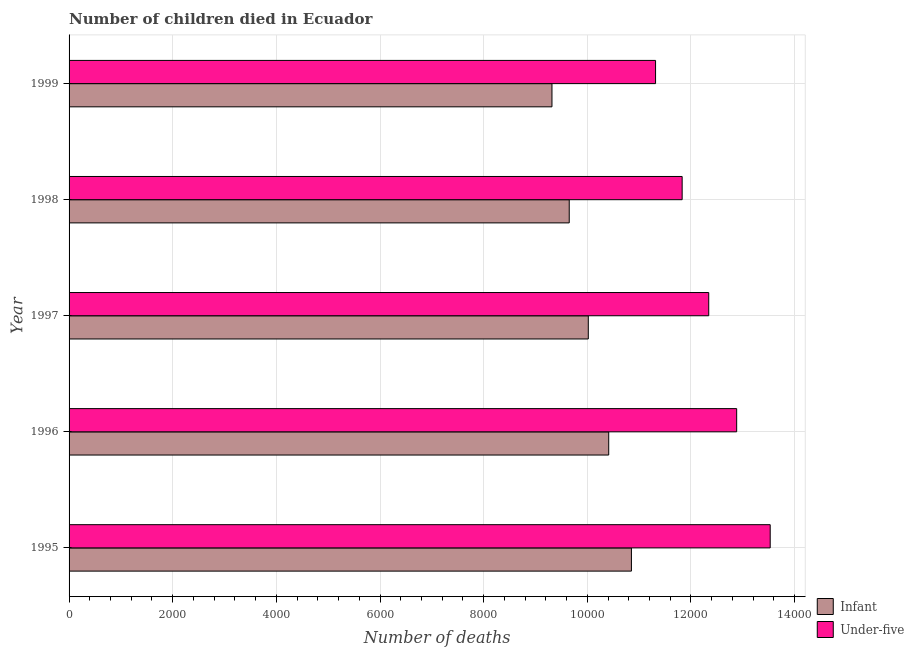How many bars are there on the 2nd tick from the top?
Offer a terse response. 2. What is the number of infant deaths in 1999?
Make the answer very short. 9318. Across all years, what is the maximum number of under-five deaths?
Keep it short and to the point. 1.35e+04. Across all years, what is the minimum number of infant deaths?
Ensure brevity in your answer.  9318. What is the total number of infant deaths in the graph?
Your answer should be very brief. 5.03e+04. What is the difference between the number of under-five deaths in 1995 and that in 1998?
Keep it short and to the point. 1699. What is the difference between the number of infant deaths in 1997 and the number of under-five deaths in 1996?
Your answer should be compact. -2863. What is the average number of infant deaths per year?
Offer a very short reply. 1.01e+04. In the year 1998, what is the difference between the number of under-five deaths and number of infant deaths?
Offer a terse response. 2179. In how many years, is the number of under-five deaths greater than 1200 ?
Offer a very short reply. 5. What is the ratio of the number of infant deaths in 1998 to that in 1999?
Give a very brief answer. 1.04. Is the number of infant deaths in 1995 less than that in 1998?
Make the answer very short. No. Is the difference between the number of under-five deaths in 1996 and 1999 greater than the difference between the number of infant deaths in 1996 and 1999?
Your answer should be very brief. Yes. What is the difference between the highest and the second highest number of under-five deaths?
Give a very brief answer. 647. What is the difference between the highest and the lowest number of under-five deaths?
Provide a short and direct response. 2212. Is the sum of the number of under-five deaths in 1995 and 1997 greater than the maximum number of infant deaths across all years?
Offer a terse response. Yes. What does the 2nd bar from the top in 1997 represents?
Give a very brief answer. Infant. What does the 1st bar from the bottom in 1995 represents?
Provide a succinct answer. Infant. How many years are there in the graph?
Provide a short and direct response. 5. What is the difference between two consecutive major ticks on the X-axis?
Keep it short and to the point. 2000. Are the values on the major ticks of X-axis written in scientific E-notation?
Provide a succinct answer. No. Does the graph contain grids?
Provide a succinct answer. Yes. How many legend labels are there?
Keep it short and to the point. 2. What is the title of the graph?
Provide a succinct answer. Number of children died in Ecuador. What is the label or title of the X-axis?
Offer a very short reply. Number of deaths. What is the label or title of the Y-axis?
Your answer should be very brief. Year. What is the Number of deaths in Infant in 1995?
Your answer should be compact. 1.09e+04. What is the Number of deaths of Under-five in 1995?
Keep it short and to the point. 1.35e+04. What is the Number of deaths of Infant in 1996?
Give a very brief answer. 1.04e+04. What is the Number of deaths of Under-five in 1996?
Offer a very short reply. 1.29e+04. What is the Number of deaths in Infant in 1997?
Your response must be concise. 1.00e+04. What is the Number of deaths in Under-five in 1997?
Keep it short and to the point. 1.23e+04. What is the Number of deaths of Infant in 1998?
Your response must be concise. 9651. What is the Number of deaths of Under-five in 1998?
Your answer should be very brief. 1.18e+04. What is the Number of deaths of Infant in 1999?
Offer a terse response. 9318. What is the Number of deaths of Under-five in 1999?
Provide a short and direct response. 1.13e+04. Across all years, what is the maximum Number of deaths in Infant?
Make the answer very short. 1.09e+04. Across all years, what is the maximum Number of deaths of Under-five?
Provide a short and direct response. 1.35e+04. Across all years, what is the minimum Number of deaths in Infant?
Provide a short and direct response. 9318. Across all years, what is the minimum Number of deaths in Under-five?
Your answer should be compact. 1.13e+04. What is the total Number of deaths in Infant in the graph?
Provide a short and direct response. 5.03e+04. What is the total Number of deaths in Under-five in the graph?
Ensure brevity in your answer.  6.19e+04. What is the difference between the Number of deaths of Infant in 1995 and that in 1996?
Offer a very short reply. 438. What is the difference between the Number of deaths in Under-five in 1995 and that in 1996?
Provide a short and direct response. 647. What is the difference between the Number of deaths in Infant in 1995 and that in 1997?
Your answer should be very brief. 832. What is the difference between the Number of deaths in Under-five in 1995 and that in 1997?
Offer a terse response. 1186. What is the difference between the Number of deaths of Infant in 1995 and that in 1998?
Provide a short and direct response. 1200. What is the difference between the Number of deaths in Under-five in 1995 and that in 1998?
Give a very brief answer. 1699. What is the difference between the Number of deaths in Infant in 1995 and that in 1999?
Make the answer very short. 1533. What is the difference between the Number of deaths of Under-five in 1995 and that in 1999?
Make the answer very short. 2212. What is the difference between the Number of deaths of Infant in 1996 and that in 1997?
Offer a terse response. 394. What is the difference between the Number of deaths in Under-five in 1996 and that in 1997?
Your response must be concise. 539. What is the difference between the Number of deaths in Infant in 1996 and that in 1998?
Offer a very short reply. 762. What is the difference between the Number of deaths of Under-five in 1996 and that in 1998?
Offer a very short reply. 1052. What is the difference between the Number of deaths of Infant in 1996 and that in 1999?
Provide a succinct answer. 1095. What is the difference between the Number of deaths in Under-five in 1996 and that in 1999?
Make the answer very short. 1565. What is the difference between the Number of deaths of Infant in 1997 and that in 1998?
Offer a terse response. 368. What is the difference between the Number of deaths of Under-five in 1997 and that in 1998?
Ensure brevity in your answer.  513. What is the difference between the Number of deaths in Infant in 1997 and that in 1999?
Ensure brevity in your answer.  701. What is the difference between the Number of deaths of Under-five in 1997 and that in 1999?
Your response must be concise. 1026. What is the difference between the Number of deaths of Infant in 1998 and that in 1999?
Your answer should be compact. 333. What is the difference between the Number of deaths in Under-five in 1998 and that in 1999?
Ensure brevity in your answer.  513. What is the difference between the Number of deaths in Infant in 1995 and the Number of deaths in Under-five in 1996?
Offer a very short reply. -2031. What is the difference between the Number of deaths of Infant in 1995 and the Number of deaths of Under-five in 1997?
Your response must be concise. -1492. What is the difference between the Number of deaths of Infant in 1995 and the Number of deaths of Under-five in 1998?
Make the answer very short. -979. What is the difference between the Number of deaths in Infant in 1995 and the Number of deaths in Under-five in 1999?
Provide a succinct answer. -466. What is the difference between the Number of deaths of Infant in 1996 and the Number of deaths of Under-five in 1997?
Your answer should be very brief. -1930. What is the difference between the Number of deaths in Infant in 1996 and the Number of deaths in Under-five in 1998?
Give a very brief answer. -1417. What is the difference between the Number of deaths in Infant in 1996 and the Number of deaths in Under-five in 1999?
Keep it short and to the point. -904. What is the difference between the Number of deaths of Infant in 1997 and the Number of deaths of Under-five in 1998?
Make the answer very short. -1811. What is the difference between the Number of deaths in Infant in 1997 and the Number of deaths in Under-five in 1999?
Your answer should be compact. -1298. What is the difference between the Number of deaths in Infant in 1998 and the Number of deaths in Under-five in 1999?
Your response must be concise. -1666. What is the average Number of deaths of Infant per year?
Provide a succinct answer. 1.01e+04. What is the average Number of deaths of Under-five per year?
Provide a short and direct response. 1.24e+04. In the year 1995, what is the difference between the Number of deaths in Infant and Number of deaths in Under-five?
Offer a very short reply. -2678. In the year 1996, what is the difference between the Number of deaths of Infant and Number of deaths of Under-five?
Offer a very short reply. -2469. In the year 1997, what is the difference between the Number of deaths in Infant and Number of deaths in Under-five?
Your answer should be very brief. -2324. In the year 1998, what is the difference between the Number of deaths in Infant and Number of deaths in Under-five?
Ensure brevity in your answer.  -2179. In the year 1999, what is the difference between the Number of deaths in Infant and Number of deaths in Under-five?
Your response must be concise. -1999. What is the ratio of the Number of deaths of Infant in 1995 to that in 1996?
Ensure brevity in your answer.  1.04. What is the ratio of the Number of deaths of Under-five in 1995 to that in 1996?
Offer a terse response. 1.05. What is the ratio of the Number of deaths of Infant in 1995 to that in 1997?
Provide a short and direct response. 1.08. What is the ratio of the Number of deaths of Under-five in 1995 to that in 1997?
Provide a succinct answer. 1.1. What is the ratio of the Number of deaths of Infant in 1995 to that in 1998?
Provide a succinct answer. 1.12. What is the ratio of the Number of deaths in Under-five in 1995 to that in 1998?
Provide a succinct answer. 1.14. What is the ratio of the Number of deaths in Infant in 1995 to that in 1999?
Provide a short and direct response. 1.16. What is the ratio of the Number of deaths of Under-five in 1995 to that in 1999?
Offer a very short reply. 1.2. What is the ratio of the Number of deaths of Infant in 1996 to that in 1997?
Give a very brief answer. 1.04. What is the ratio of the Number of deaths of Under-five in 1996 to that in 1997?
Ensure brevity in your answer.  1.04. What is the ratio of the Number of deaths of Infant in 1996 to that in 1998?
Provide a short and direct response. 1.08. What is the ratio of the Number of deaths of Under-five in 1996 to that in 1998?
Your answer should be very brief. 1.09. What is the ratio of the Number of deaths in Infant in 1996 to that in 1999?
Give a very brief answer. 1.12. What is the ratio of the Number of deaths of Under-five in 1996 to that in 1999?
Your response must be concise. 1.14. What is the ratio of the Number of deaths in Infant in 1997 to that in 1998?
Offer a terse response. 1.04. What is the ratio of the Number of deaths in Under-five in 1997 to that in 1998?
Make the answer very short. 1.04. What is the ratio of the Number of deaths of Infant in 1997 to that in 1999?
Provide a short and direct response. 1.08. What is the ratio of the Number of deaths of Under-five in 1997 to that in 1999?
Your answer should be compact. 1.09. What is the ratio of the Number of deaths of Infant in 1998 to that in 1999?
Keep it short and to the point. 1.04. What is the ratio of the Number of deaths in Under-five in 1998 to that in 1999?
Provide a short and direct response. 1.05. What is the difference between the highest and the second highest Number of deaths in Infant?
Offer a terse response. 438. What is the difference between the highest and the second highest Number of deaths in Under-five?
Ensure brevity in your answer.  647. What is the difference between the highest and the lowest Number of deaths in Infant?
Keep it short and to the point. 1533. What is the difference between the highest and the lowest Number of deaths in Under-five?
Your answer should be compact. 2212. 